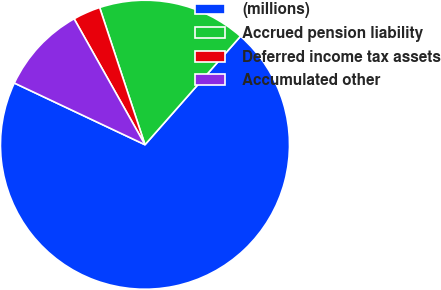<chart> <loc_0><loc_0><loc_500><loc_500><pie_chart><fcel>(millions)<fcel>Accrued pension liability<fcel>Deferred income tax assets<fcel>Accumulated other<nl><fcel>70.53%<fcel>16.57%<fcel>3.08%<fcel>9.82%<nl></chart> 